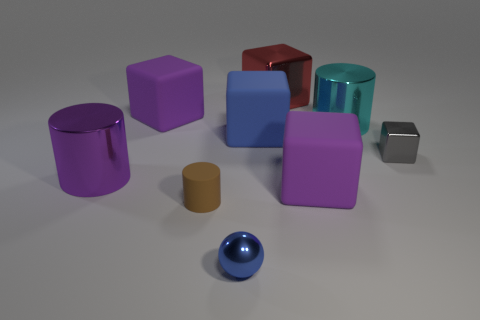Can you tell me the colors of the cylinders in the image? Certainly! In the image, there are cylinders in cyan, green, and purple colors. 